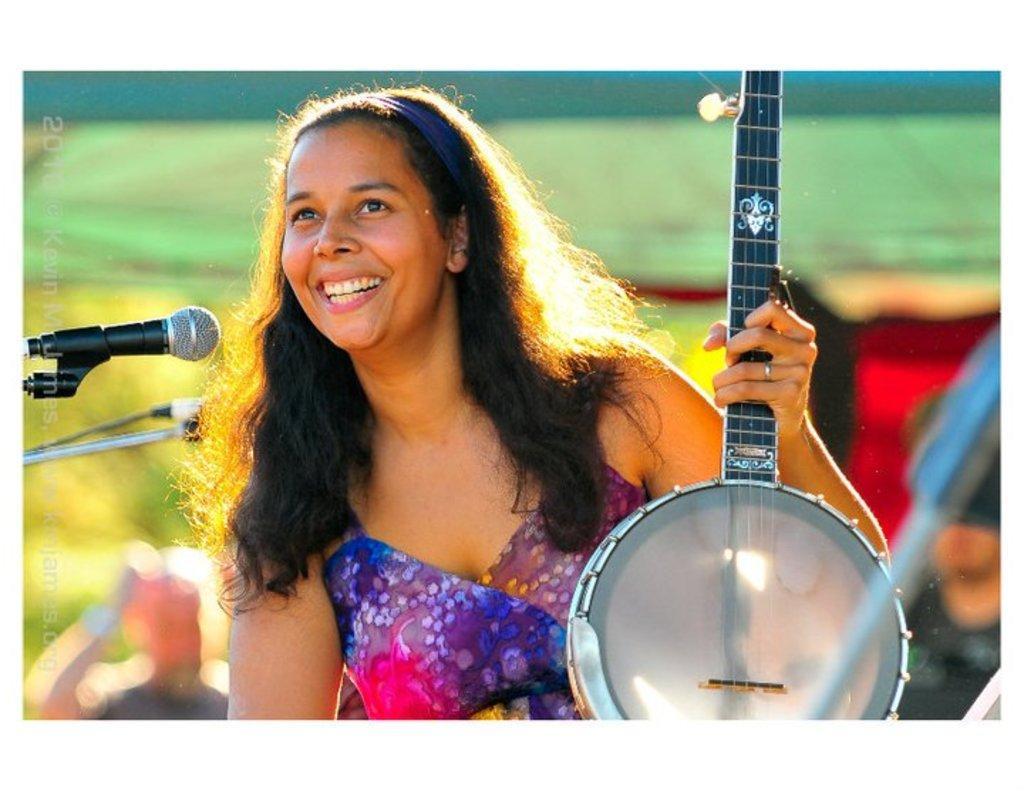Please provide a concise description of this image. In this image, there is a person wearing clothes and holding a musical instrument with her hand. There is a mic on the left side of the image. 